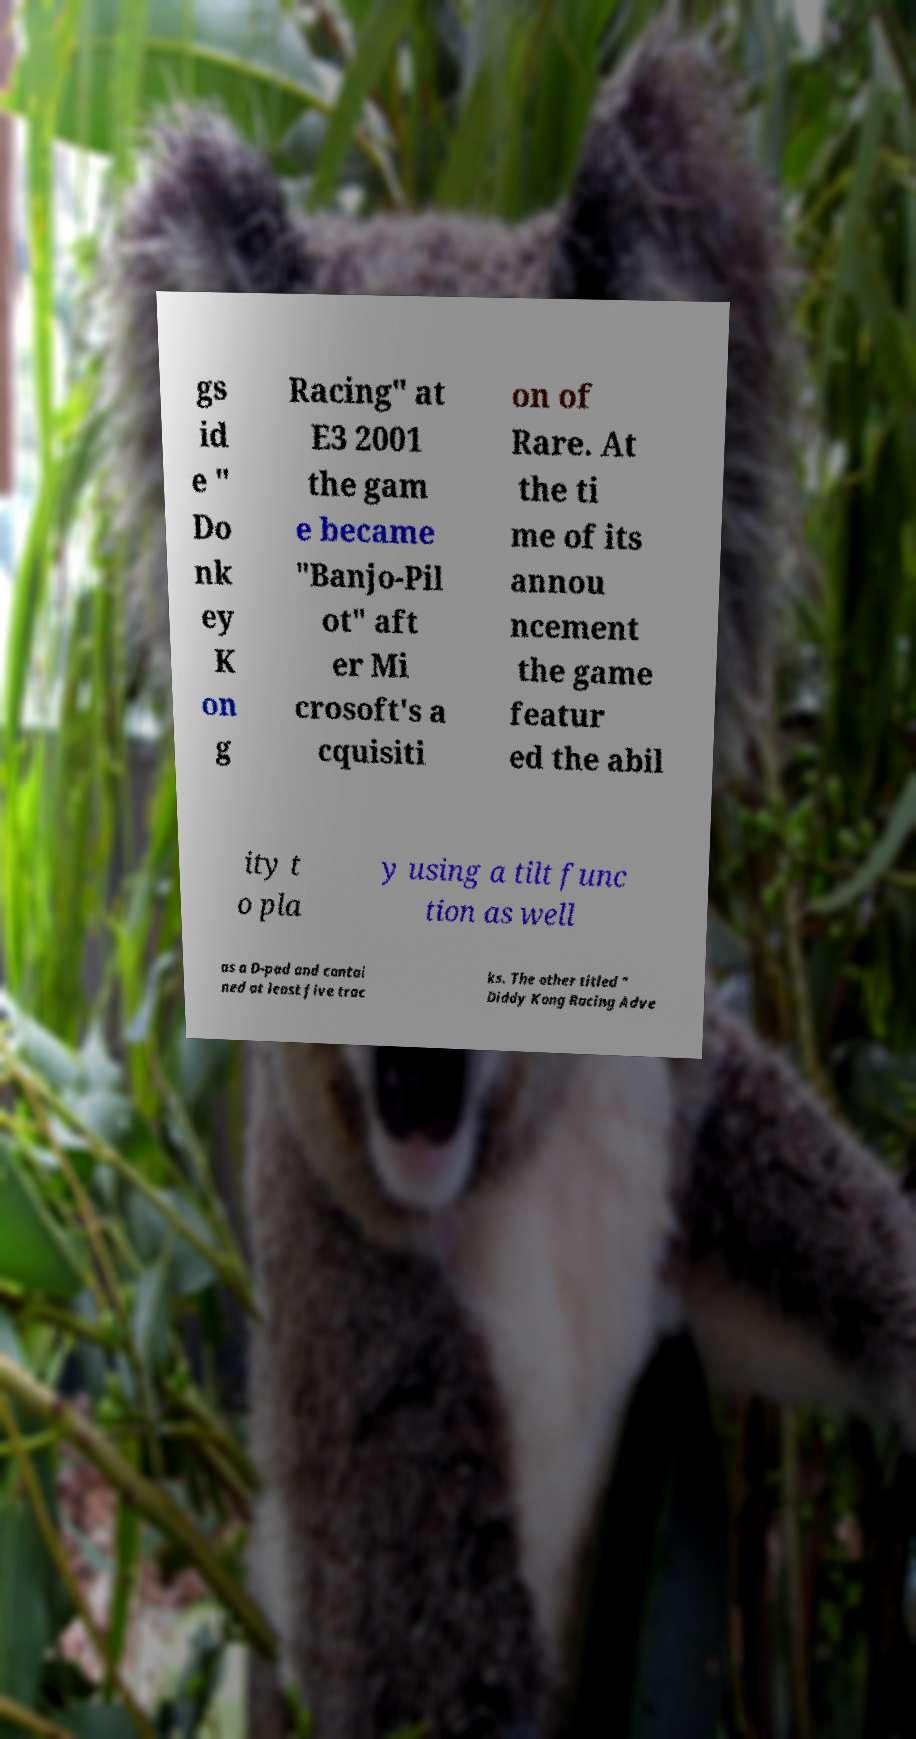What messages or text are displayed in this image? I need them in a readable, typed format. gs id e " Do nk ey K on g Racing" at E3 2001 the gam e became "Banjo-Pil ot" aft er Mi crosoft's a cquisiti on of Rare. At the ti me of its annou ncement the game featur ed the abil ity t o pla y using a tilt func tion as well as a D-pad and contai ned at least five trac ks. The other titled " Diddy Kong Racing Adve 